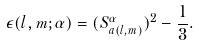<formula> <loc_0><loc_0><loc_500><loc_500>\epsilon ( l , m ; \alpha ) = ( S ^ { \alpha } _ { a ( l , m ) } ) ^ { 2 } - \frac { 1 } { 3 } .</formula> 